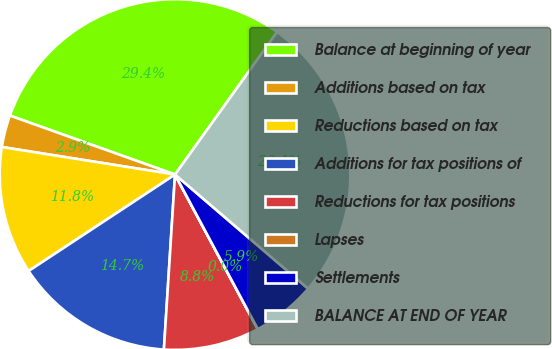Convert chart to OTSL. <chart><loc_0><loc_0><loc_500><loc_500><pie_chart><fcel>Balance at beginning of year<fcel>Additions based on tax<fcel>Reductions based on tax<fcel>Additions for tax positions of<fcel>Reductions for tax positions<fcel>Lapses<fcel>Settlements<fcel>BALANCE AT END OF YEAR<nl><fcel>29.44%<fcel>2.95%<fcel>11.78%<fcel>14.72%<fcel>8.83%<fcel>0.01%<fcel>5.89%<fcel>26.39%<nl></chart> 